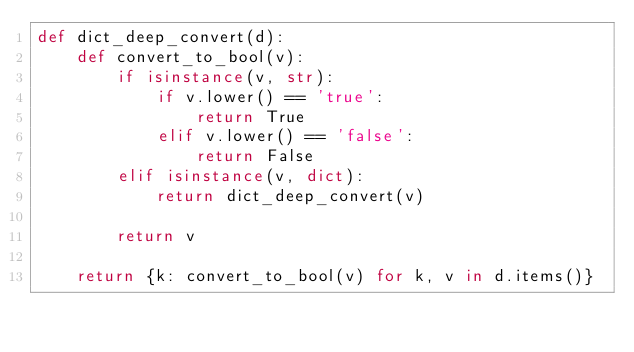Convert code to text. <code><loc_0><loc_0><loc_500><loc_500><_Python_>def dict_deep_convert(d):
    def convert_to_bool(v):
        if isinstance(v, str):
            if v.lower() == 'true':
                return True
            elif v.lower() == 'false':
                return False
        elif isinstance(v, dict):
            return dict_deep_convert(v)

        return v

    return {k: convert_to_bool(v) for k, v in d.items()}</code> 